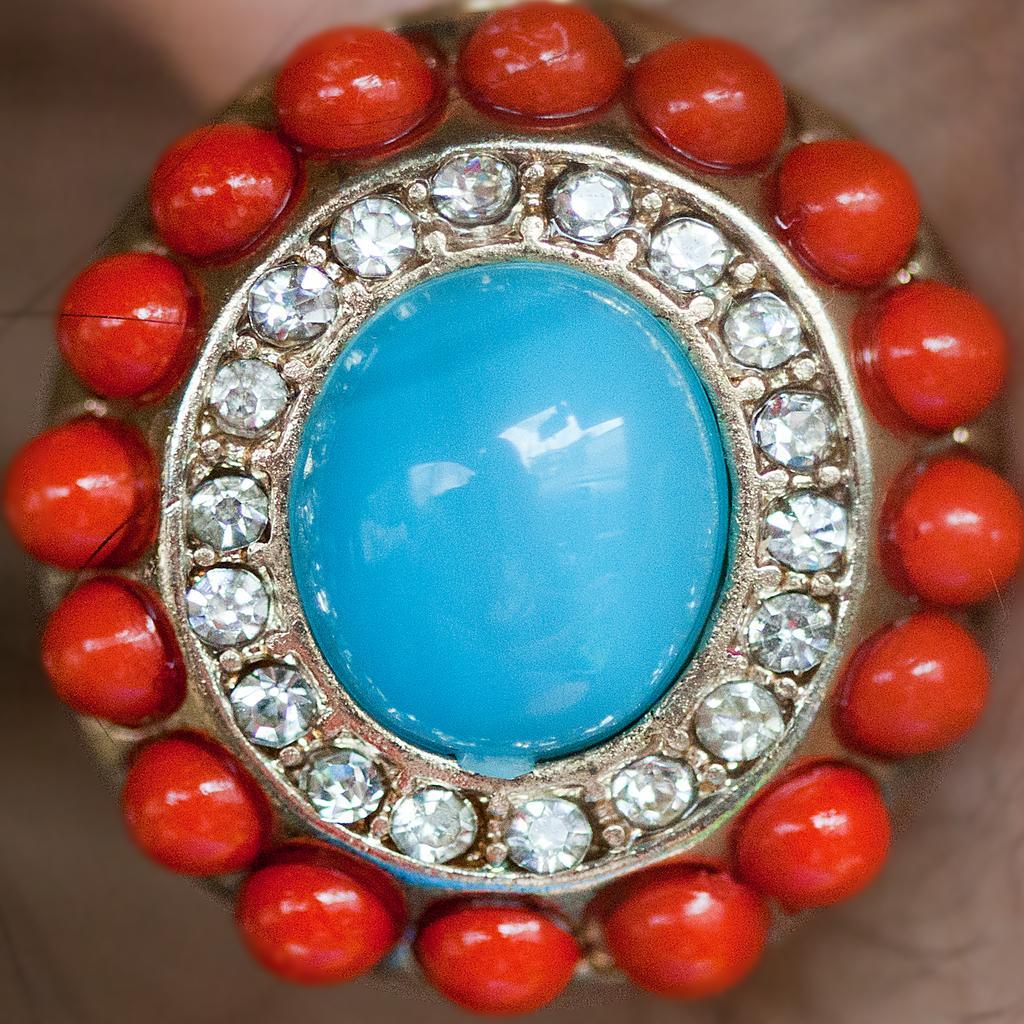What object is being held by a person in the image? There is a locket in the image, and it is being held by a person. What type of food is the cook preparing for the boys in the image? There is no cook, food, or boys present in the image; it only features a person holding a locket. 